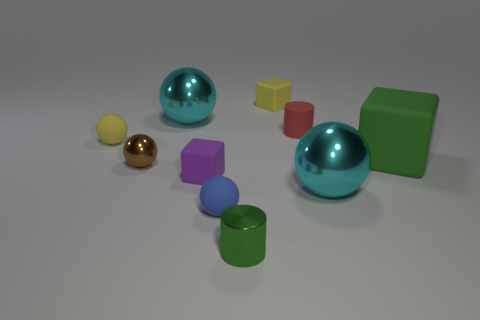The cyan object that is on the left side of the cyan sphere in front of the red thing is what shape?
Your answer should be compact. Sphere. Do the red cylinder and the large cyan sphere that is in front of the tiny red matte thing have the same material?
Your answer should be very brief. No. There is a metallic thing that is the same color as the large block; what shape is it?
Your answer should be compact. Cylinder. What number of gray cylinders are the same size as the green metallic thing?
Keep it short and to the point. 0. Are there fewer green cylinders left of the blue matte sphere than small purple rubber things?
Offer a very short reply. Yes. There is a small blue thing; how many tiny green metal cylinders are to the left of it?
Your response must be concise. 0. There is a yellow thing on the right side of the cyan sphere that is behind the small yellow object in front of the small yellow cube; what is its size?
Provide a short and direct response. Small. Do the red rubber thing and the small brown object behind the blue ball have the same shape?
Ensure brevity in your answer.  No. There is a cylinder that is made of the same material as the tiny yellow block; what size is it?
Give a very brief answer. Small. Is there anything else that has the same color as the tiny matte cylinder?
Make the answer very short. No. 